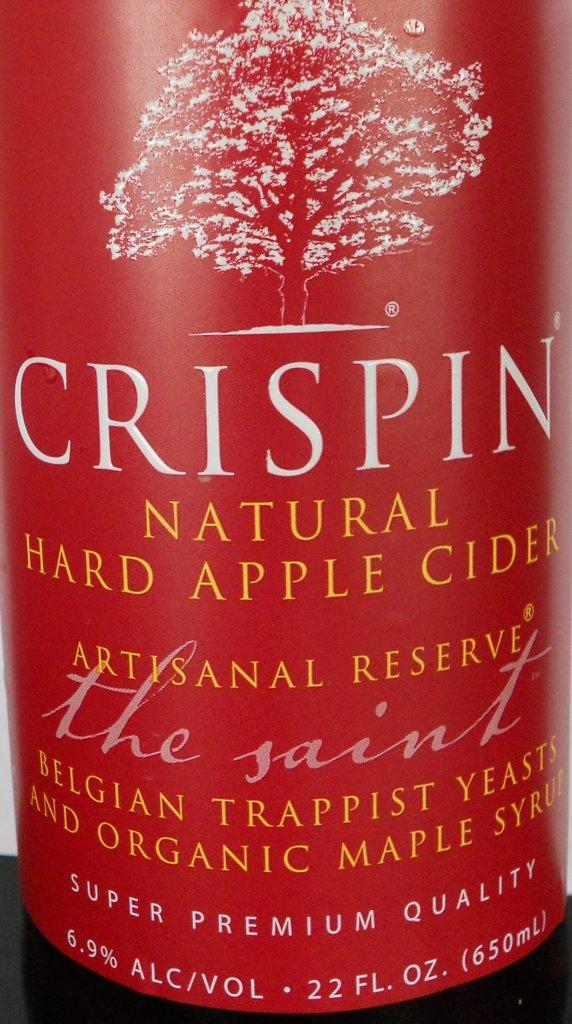What is the main subject of the poster in the image? The poster contains a depiction of a tree. What else can be found on the poster besides the tree? The poster also has information on it. What is the color of the surface at the bottom of the image? The surface at the bottom of the image is black. Can you see any fog surrounding the tree in the image? There is no fog present in the image; it only features a poster with a depiction of a tree and some information. 